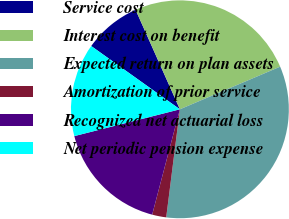Convert chart to OTSL. <chart><loc_0><loc_0><loc_500><loc_500><pie_chart><fcel>Service cost<fcel>Interest cost on benefit<fcel>Expected return on plan assets<fcel>Amortization of prior service<fcel>Recognized net actuarial loss<fcel>Net periodic pension expense<nl><fcel>8.47%<fcel>25.27%<fcel>33.41%<fcel>2.09%<fcel>16.95%<fcel>13.82%<nl></chart> 